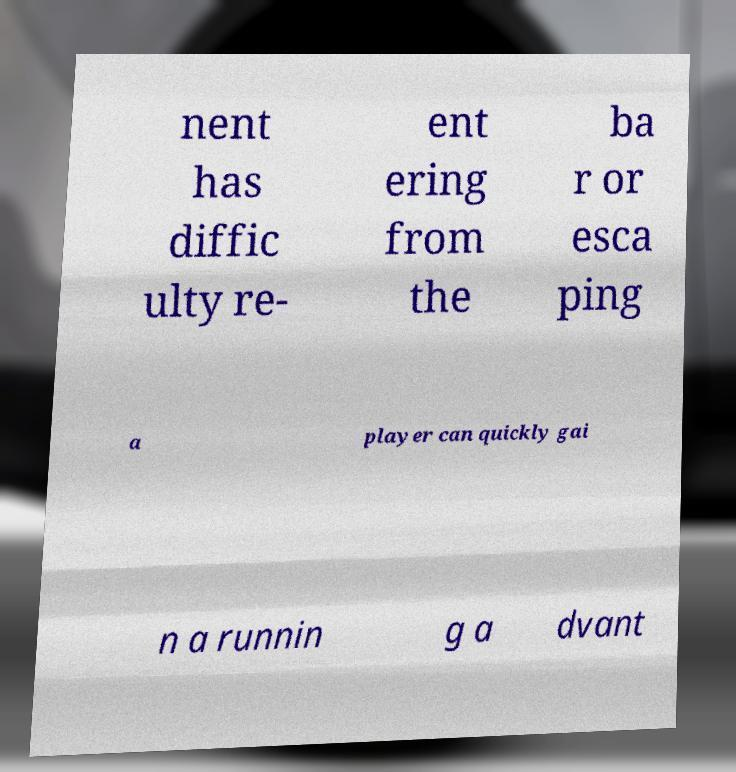Can you accurately transcribe the text from the provided image for me? nent has diffic ulty re- ent ering from the ba r or esca ping a player can quickly gai n a runnin g a dvant 